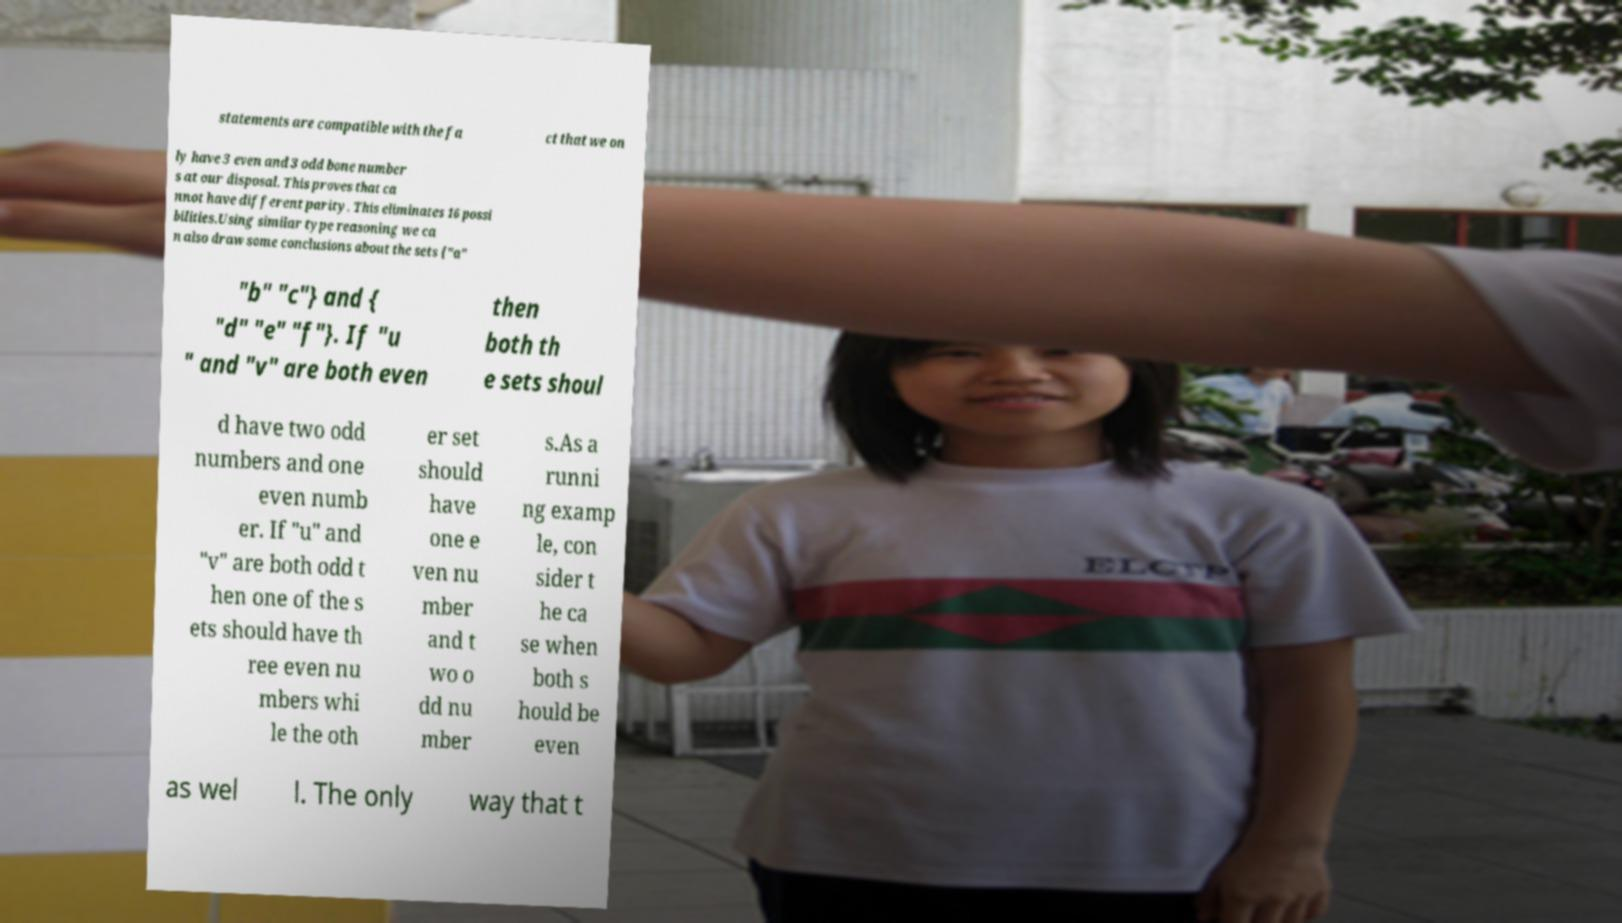Please read and relay the text visible in this image. What does it say? statements are compatible with the fa ct that we on ly have 3 even and 3 odd bone number s at our disposal. This proves that ca nnot have different parity. This eliminates 16 possi bilities.Using similar type reasoning we ca n also draw some conclusions about the sets {"a" "b" "c"} and { "d" "e" "f"}. If "u " and "v" are both even then both th e sets shoul d have two odd numbers and one even numb er. If "u" and "v" are both odd t hen one of the s ets should have th ree even nu mbers whi le the oth er set should have one e ven nu mber and t wo o dd nu mber s.As a runni ng examp le, con sider t he ca se when both s hould be even as wel l. The only way that t 